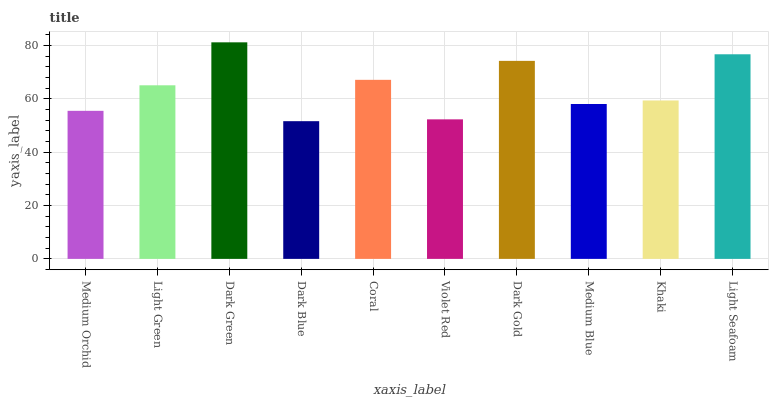Is Dark Blue the minimum?
Answer yes or no. Yes. Is Dark Green the maximum?
Answer yes or no. Yes. Is Light Green the minimum?
Answer yes or no. No. Is Light Green the maximum?
Answer yes or no. No. Is Light Green greater than Medium Orchid?
Answer yes or no. Yes. Is Medium Orchid less than Light Green?
Answer yes or no. Yes. Is Medium Orchid greater than Light Green?
Answer yes or no. No. Is Light Green less than Medium Orchid?
Answer yes or no. No. Is Light Green the high median?
Answer yes or no. Yes. Is Khaki the low median?
Answer yes or no. Yes. Is Light Seafoam the high median?
Answer yes or no. No. Is Dark Blue the low median?
Answer yes or no. No. 